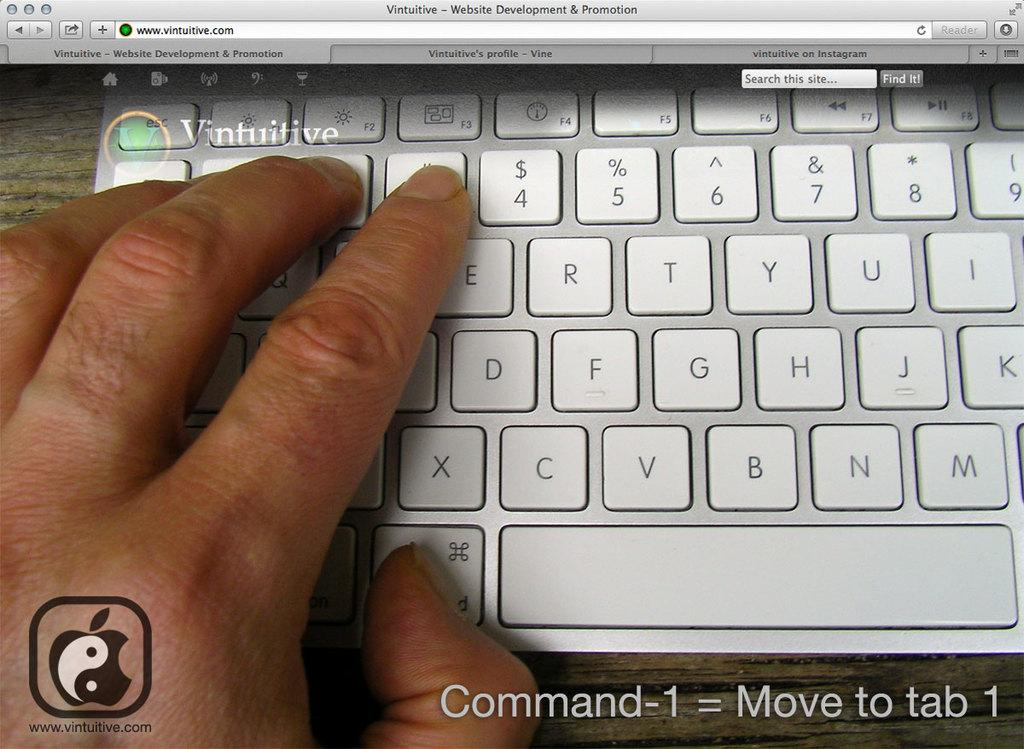<image>
Relay a brief, clear account of the picture shown. Command-1 = Move to tab 1 is captioned below this keyboard. 